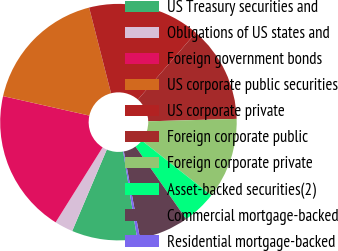Convert chart. <chart><loc_0><loc_0><loc_500><loc_500><pie_chart><fcel>US Treasury securities and<fcel>Obligations of US states and<fcel>Foreign government bonds<fcel>US corporate public securities<fcel>US corporate private<fcel>Foreign corporate public<fcel>Foreign corporate private<fcel>Asset-backed securities(2)<fcel>Commercial mortgage-backed<fcel>Residential mortgage-backed<nl><fcel>8.93%<fcel>2.52%<fcel>19.62%<fcel>17.48%<fcel>15.34%<fcel>13.21%<fcel>11.07%<fcel>4.66%<fcel>6.79%<fcel>0.38%<nl></chart> 